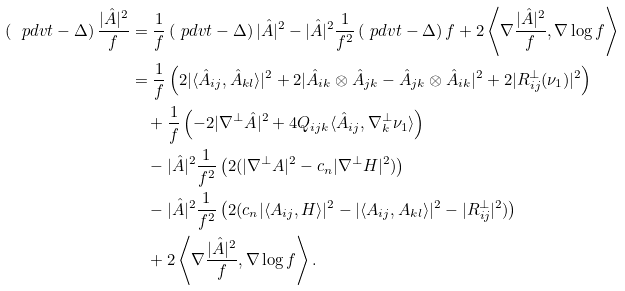<formula> <loc_0><loc_0><loc_500><loc_500>\left ( \ p d v { t } - \Delta \right ) \frac { | \hat { A } | ^ { 2 } } { f } & = \frac { 1 } { f } \left ( \ p d v { t } - \Delta \right ) | \hat { A } | ^ { 2 } - | \hat { A } | ^ { 2 } \frac { 1 } { f ^ { 2 } } \left ( \ p d v { t } - \Delta \right ) f + 2 \left \langle \nabla \frac { | \hat { A } | ^ { 2 } } { f } , \nabla \log f \right \rangle \\ & = \frac { 1 } { f } \left ( 2 | \langle \hat { A } _ { i j } , \hat { A } _ { k l } \rangle | ^ { 2 } + 2 | \hat { A } _ { i k } \otimes \hat { A } _ { j k } - \hat { A } _ { j k } \otimes \hat { A } _ { i k } | ^ { 2 } + 2 | R ^ { \perp } _ { i j } ( \nu _ { 1 } ) | ^ { 2 } \right ) \\ & \quad + \frac { 1 } { f } \left ( - 2 | \nabla ^ { \perp } \hat { A } | ^ { 2 } + 4 Q _ { i j k } \langle \hat { A } _ { i j } , \nabla _ { k } ^ { \perp } \nu _ { 1 } \rangle \right ) \\ & \quad - | \hat { A } | ^ { 2 } \frac { 1 } { f ^ { 2 } } \left ( 2 ( | \nabla ^ { \perp } A | ^ { 2 } - c _ { n } | \nabla ^ { \perp } H | ^ { 2 } ) \right ) \\ & \quad - | \hat { A } | ^ { 2 } \frac { 1 } { f ^ { 2 } } \left ( 2 ( c _ { n } | \langle A _ { i j } , H \rangle | ^ { 2 } - | \langle A _ { i j } , A _ { k l } \rangle | ^ { 2 } - | R ^ { \perp } _ { i j } | ^ { 2 } ) \right ) \\ & \quad + 2 \left \langle \nabla \frac { | \hat { A } | ^ { 2 } } { f } , \nabla \log f \right \rangle .</formula> 